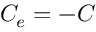<formula> <loc_0><loc_0><loc_500><loc_500>C _ { e } = - C</formula> 